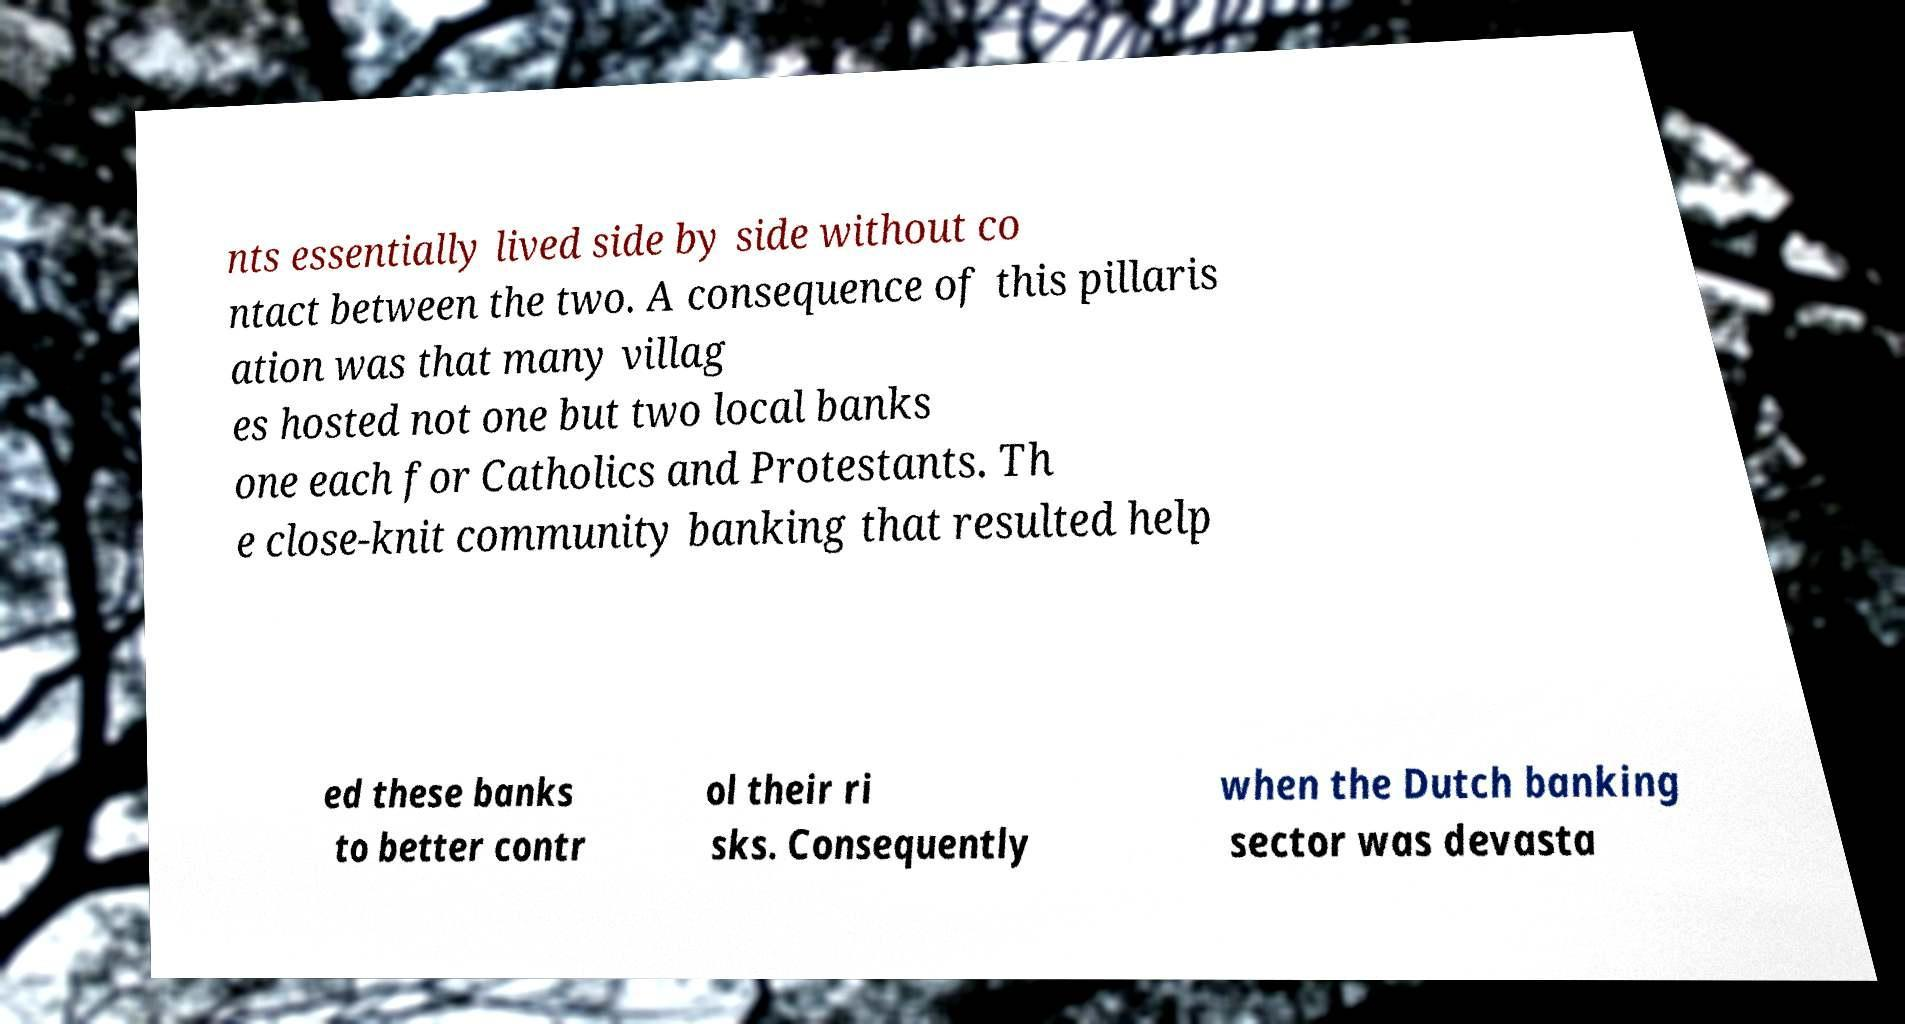Could you assist in decoding the text presented in this image and type it out clearly? nts essentially lived side by side without co ntact between the two. A consequence of this pillaris ation was that many villag es hosted not one but two local banks one each for Catholics and Protestants. Th e close-knit community banking that resulted help ed these banks to better contr ol their ri sks. Consequently when the Dutch banking sector was devasta 